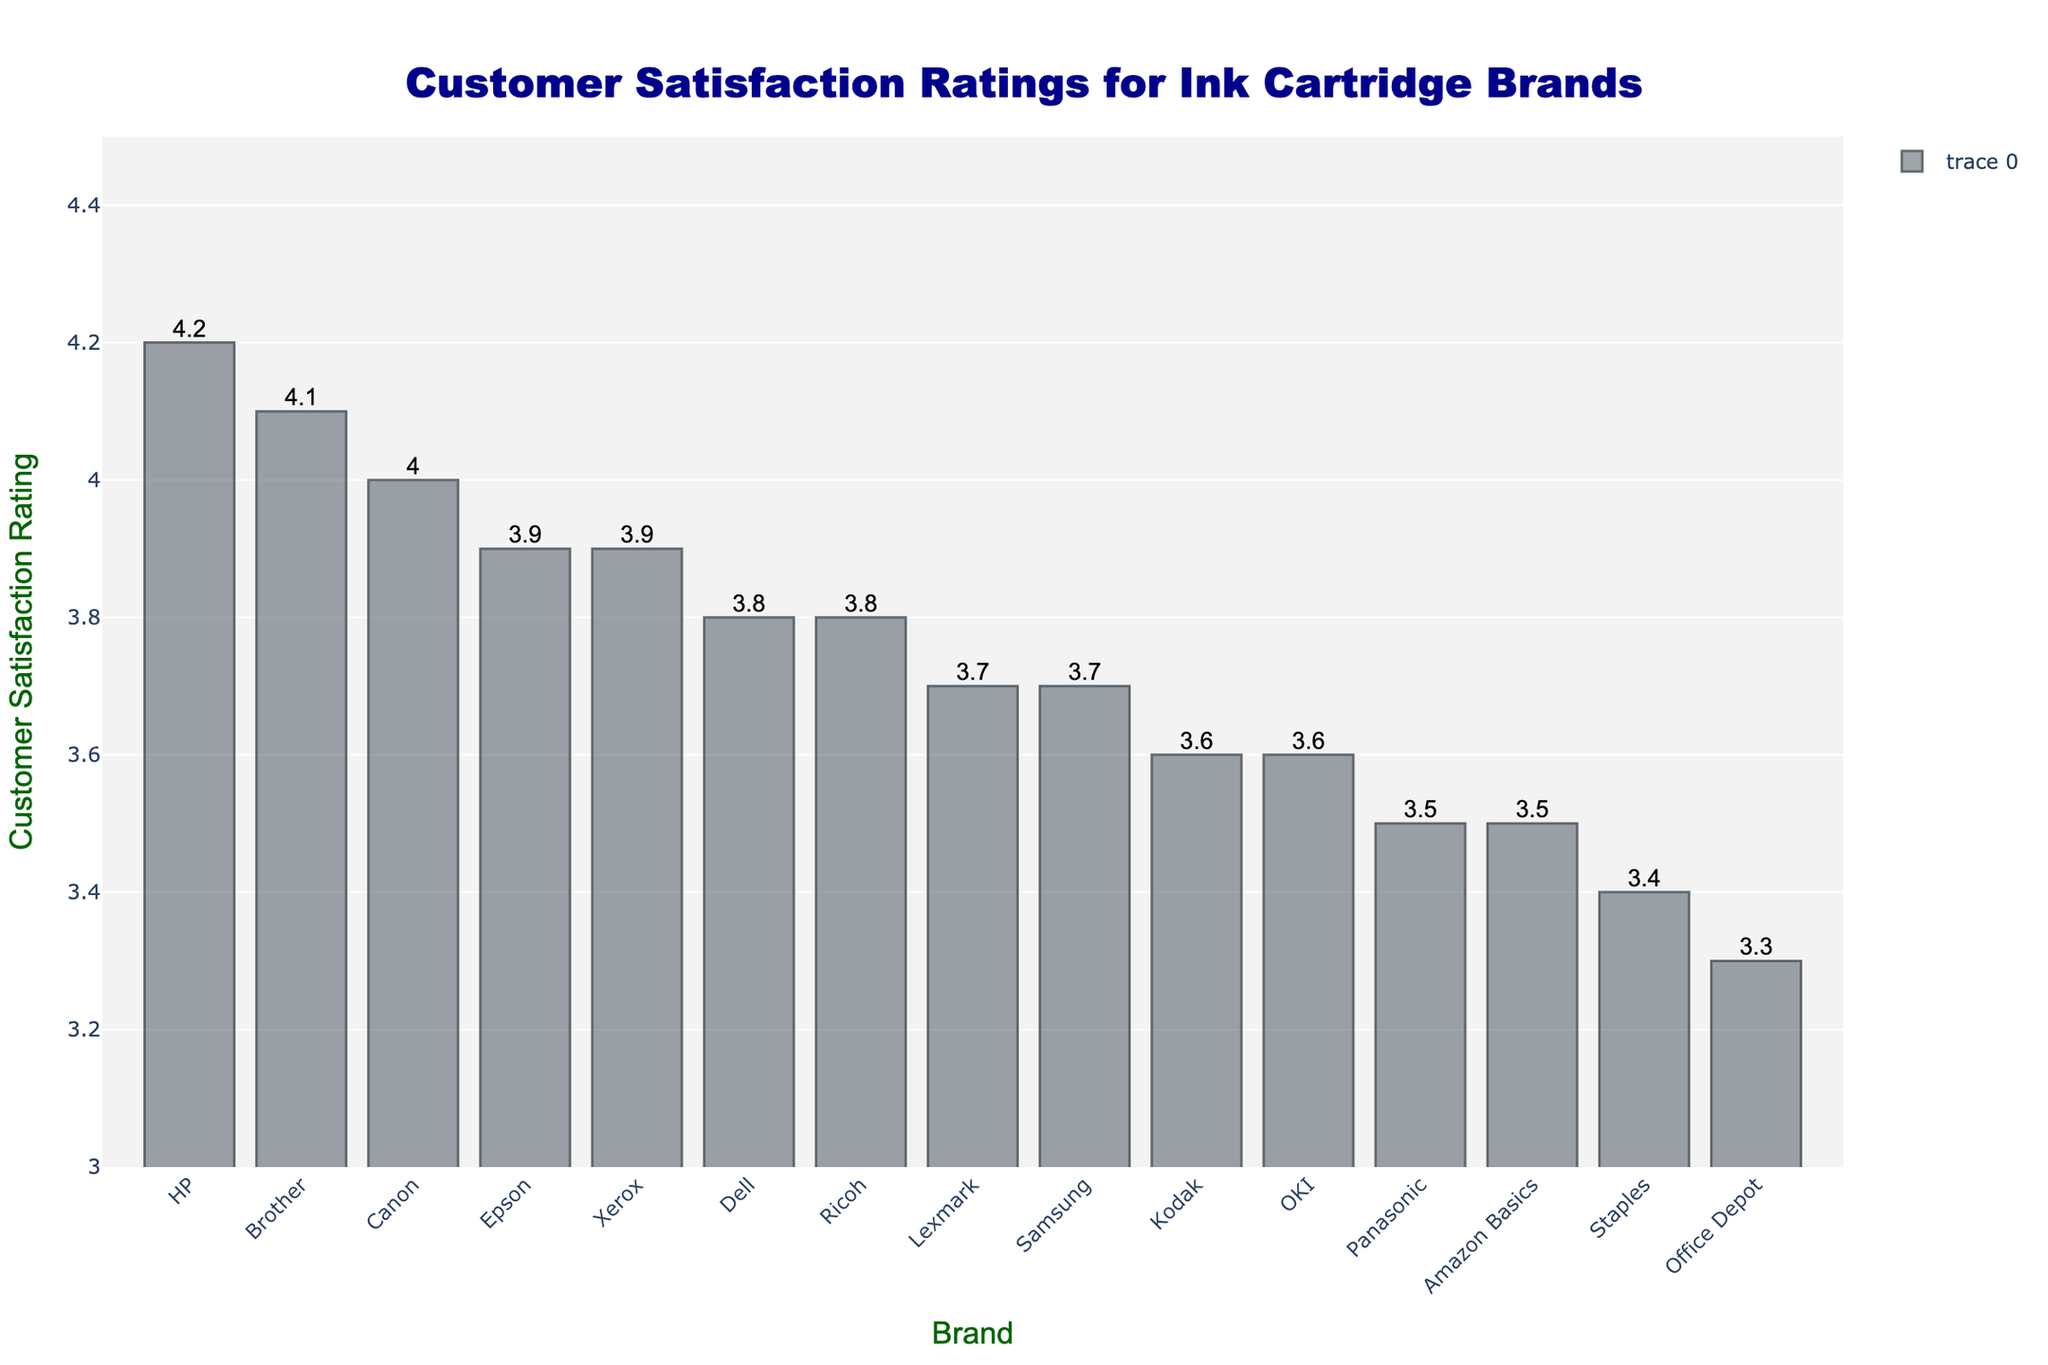Which ink cartridge brand has the highest customer satisfaction rating? The bar for the HP brand is the tallest, indicating that it has the highest customer satisfaction rating.
Answer: HP Which brand has the lowest customer satisfaction rating? The bar for Office Depot is the shortest, indicating that it has the lowest customer satisfaction rating.
Answer: Office Depot How much higher is HP's customer satisfaction rating compared to Canon's? HP has a rating of 4.2, and Canon has a rating of 4.0. The difference is 4.2 - 4.0 = 0.2.
Answer: 0.2 What is the average customer satisfaction rating of the top three brands? The top three brands are HP (4.2), Brother (4.1), and Canon (4.0). The average rating is (4.2 + 4.1 + 4.0) / 3 = 4.1.
Answer: 4.1 Which two brands have the same customer satisfaction rating, and what is it? Epson and Xerox both have the same customer satisfaction rating of 3.9, as indicated by the equal height of their bars.
Answer: Epson and Xerox, 3.9 What is the median customer satisfaction rating of all brands shown? First, list all ratings in ascending order: 3.3, 3.4, 3.5, 3.5, 3.6, 3.6, 3.7, 3.7, 3.8, 3.8, 3.9, 3.9, 4.0, 4.1, 4.2. The median rating is the middle value, which is the 8th value: 3.7.
Answer: 3.7 How does the customer satisfaction rating of Lexmark compare to Samsung? Lexmark has a rating of 3.7, and Samsung also has a rating of 3.7. Both brands have equal customer satisfaction ratings.
Answer: Equal, 3.7 If you combine the ratings of Ricoh and Dell, what is the total? Ricoh has a rating of 3.8, and Dell has a rating of 3.8. Combined, the total rating is 3.8 + 3.8 = 7.6.
Answer: 7.6 What is the difference between the highest and lowest customer satisfaction ratings? The highest rating is 4.2 (HP) and the lowest is 3.3 (Office Depot). The difference is 4.2 - 3.3 = 0.9.
Answer: 0.9 